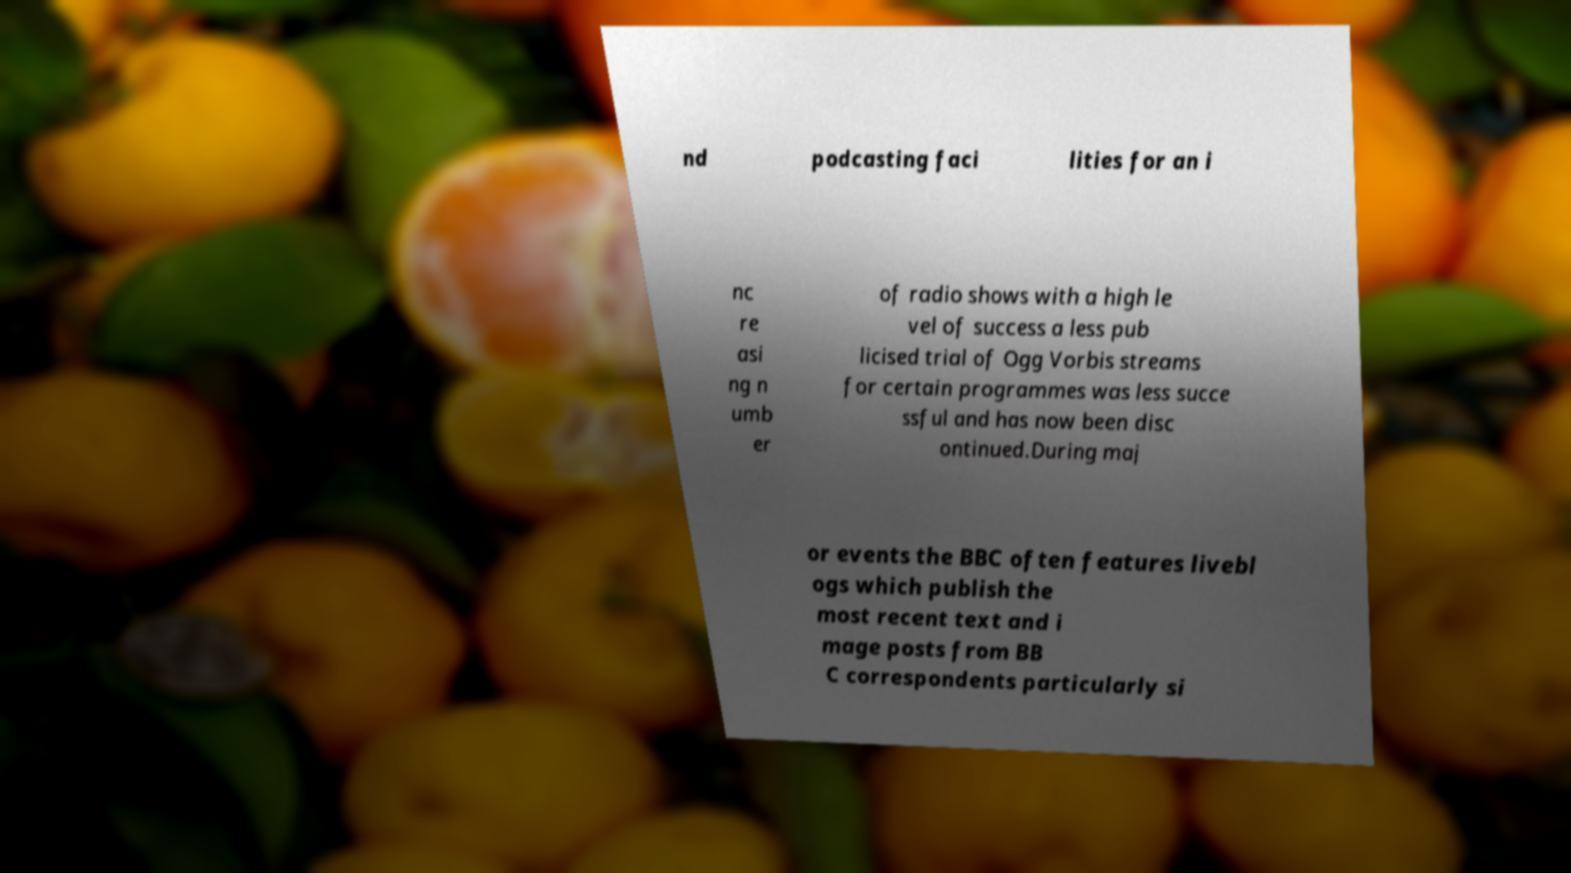I need the written content from this picture converted into text. Can you do that? nd podcasting faci lities for an i nc re asi ng n umb er of radio shows with a high le vel of success a less pub licised trial of Ogg Vorbis streams for certain programmes was less succe ssful and has now been disc ontinued.During maj or events the BBC often features livebl ogs which publish the most recent text and i mage posts from BB C correspondents particularly si 